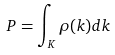<formula> <loc_0><loc_0><loc_500><loc_500>P = \int _ { K } \rho ( k ) d k</formula> 